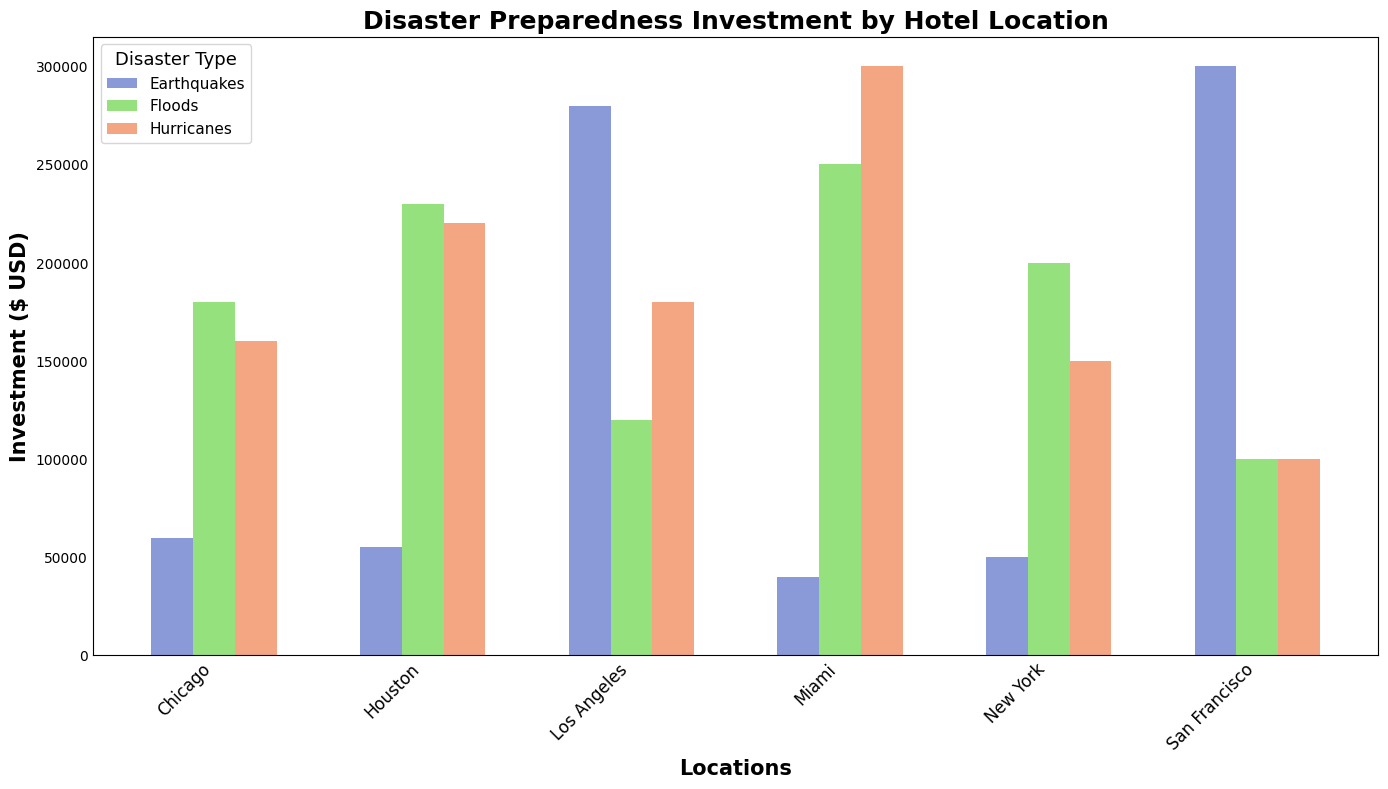What is the total investment in disaster preparedness for New York? To find the total investment for New York, sum the investments for floods, earthquakes, and hurricanes: 200,000 + 50,000 + 150,000. The total is 400,000.
Answer: 400,000 Which location has the highest investment in earthquake preparedness? By inspecting the bars representing earthquake investments for each location, San Francisco has the highest investment at 300,000.
Answer: San Francisco How does Miami's investment in hurricanes compare to Houston's? Miami's investment in hurricanes is 300,000, and Houston's is 220,000. Miami has a higher investment by 80,000.
Answer: Miami invests 80,000 more than Houston Which disaster type does Los Angeles invest in the least? Looking at the bars for Los Angeles, the smallest investment is in floods, at 120,000.
Answer: Floods What is the average investment in flood preparedness across all locations? Sum the investments in floods for all locations and then divide by the number of locations. The investments are 200,000 + 250,000 + 100,000 + 120,000 + 180,000 + 230,000 = 1,080,000. There are 6 locations, so the average is 1,080,000 / 6 = 180,000.
Answer: 180,000 Which location has the highest total investment in disaster preparedness overall? Calculate the sum of investments for each location. New York: 400,000, Miami: 590,000, San Francisco: 500,000, Los Angeles: 580,000, Chicago: 400,000, Houston: 505,000. Miami has the highest total investment, 590,000.
Answer: Miami What is the difference between the highest and lowest investments in hurricane preparedness among all locations? The highest investment is Miami with 300,000, and the lowest is San Francisco with 100,000. The difference is 300,000 - 100,000 = 200,000.
Answer: 200,000 Which disaster type does New York invest the most in? Comparing the bars for New York, the highest investment is in floods, at 200,000.
Answer: Floods 